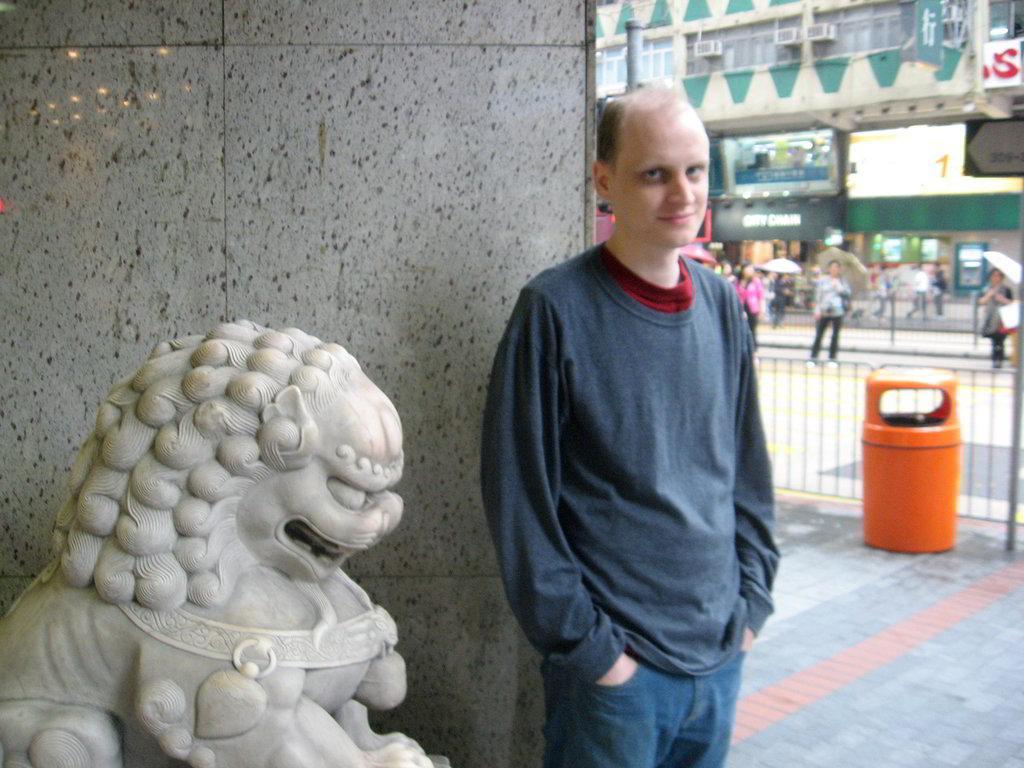How would you summarize this image in a sentence or two? As we can see in the image there are buildings, banners, group of people, umbrellas, statue and dustbin. The man standing in the front is wearing blue color t shirt. 